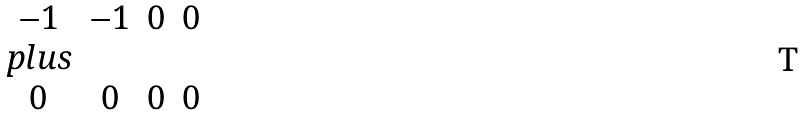Convert formula to latex. <formula><loc_0><loc_0><loc_500><loc_500>\begin{array} { c c c c } - 1 & - 1 & 0 & 0 \\ p l u s & & & \\ 0 & 0 & 0 & 0 \\ \end{array}</formula> 